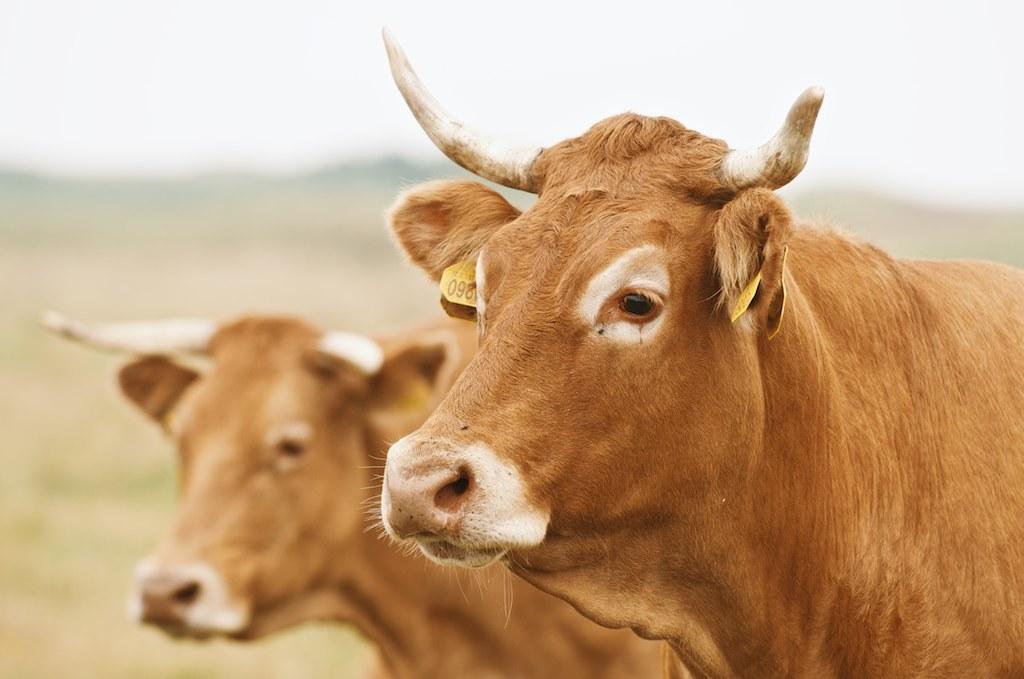In one or two sentences, can you explain what this image depicts? It is a zoomed in picture of two cows and the background is blurred. 